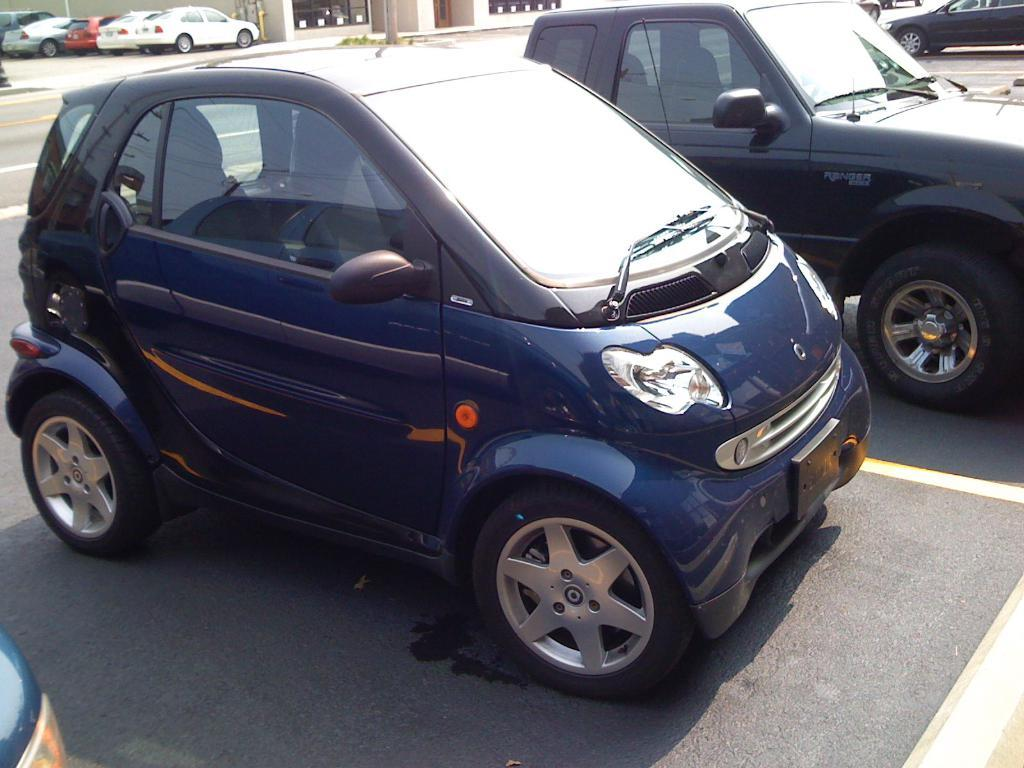What type of vehicles can be seen on the road in the image? There are cars on the road in the image. What natural element is present in the image? There is a tree trunk and grass in the image. What type of structure can be seen in the background of the image? There is a building in the background of the image. What else can be seen in the background of the image? There are a few objects in the background of the image. Is there a bridge visible in the image? No, there is no bridge present in the image. What type of metal is being used to construct the sink in the image? There is no sink present in the image, so it is not possible to determine the type of metal used. 